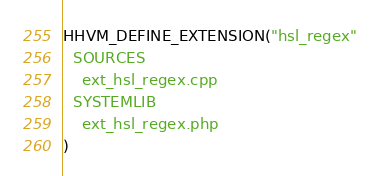<code> <loc_0><loc_0><loc_500><loc_500><_CMake_>HHVM_DEFINE_EXTENSION("hsl_regex"
  SOURCES
    ext_hsl_regex.cpp
  SYSTEMLIB
    ext_hsl_regex.php
)
</code> 